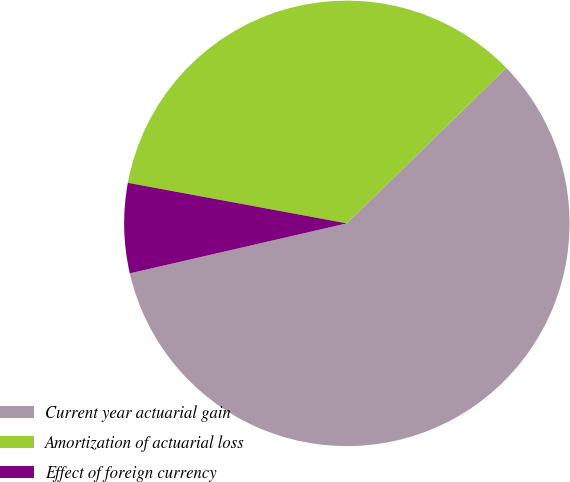Convert chart. <chart><loc_0><loc_0><loc_500><loc_500><pie_chart><fcel>Current year actuarial gain<fcel>Amortization of actuarial loss<fcel>Effect of foreign currency<nl><fcel>58.7%<fcel>34.78%<fcel>6.52%<nl></chart> 